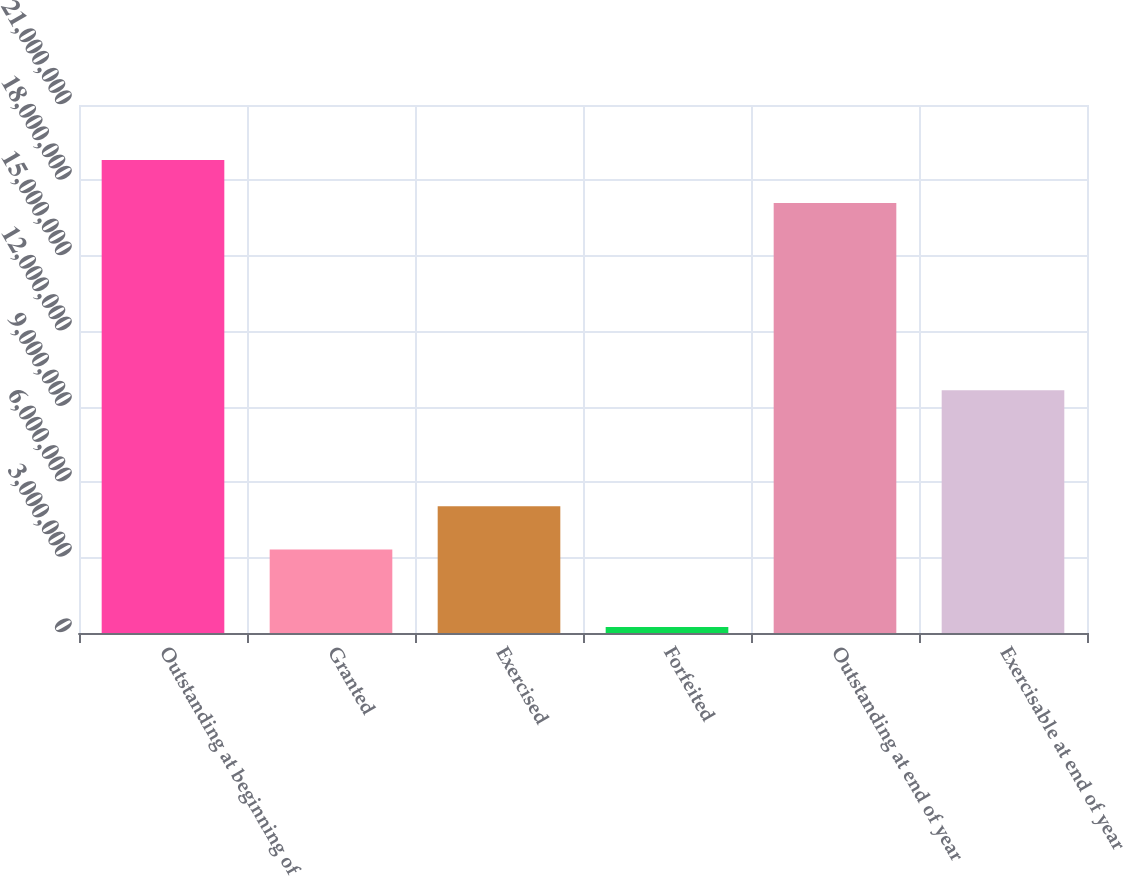<chart> <loc_0><loc_0><loc_500><loc_500><bar_chart><fcel>Outstanding at beginning of<fcel>Granted<fcel>Exercised<fcel>Forfeited<fcel>Outstanding at end of year<fcel>Exercisable at end of year<nl><fcel>1.88116e+07<fcel>3.32414e+06<fcel>5.03626e+06<fcel>238164<fcel>1.70995e+07<fcel>9.65741e+06<nl></chart> 